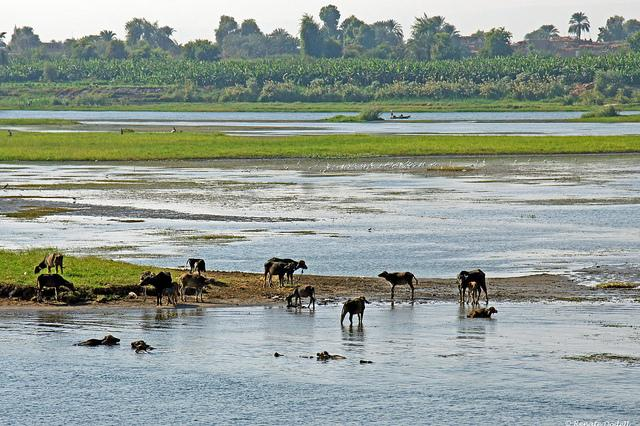What are the animals called? cows 